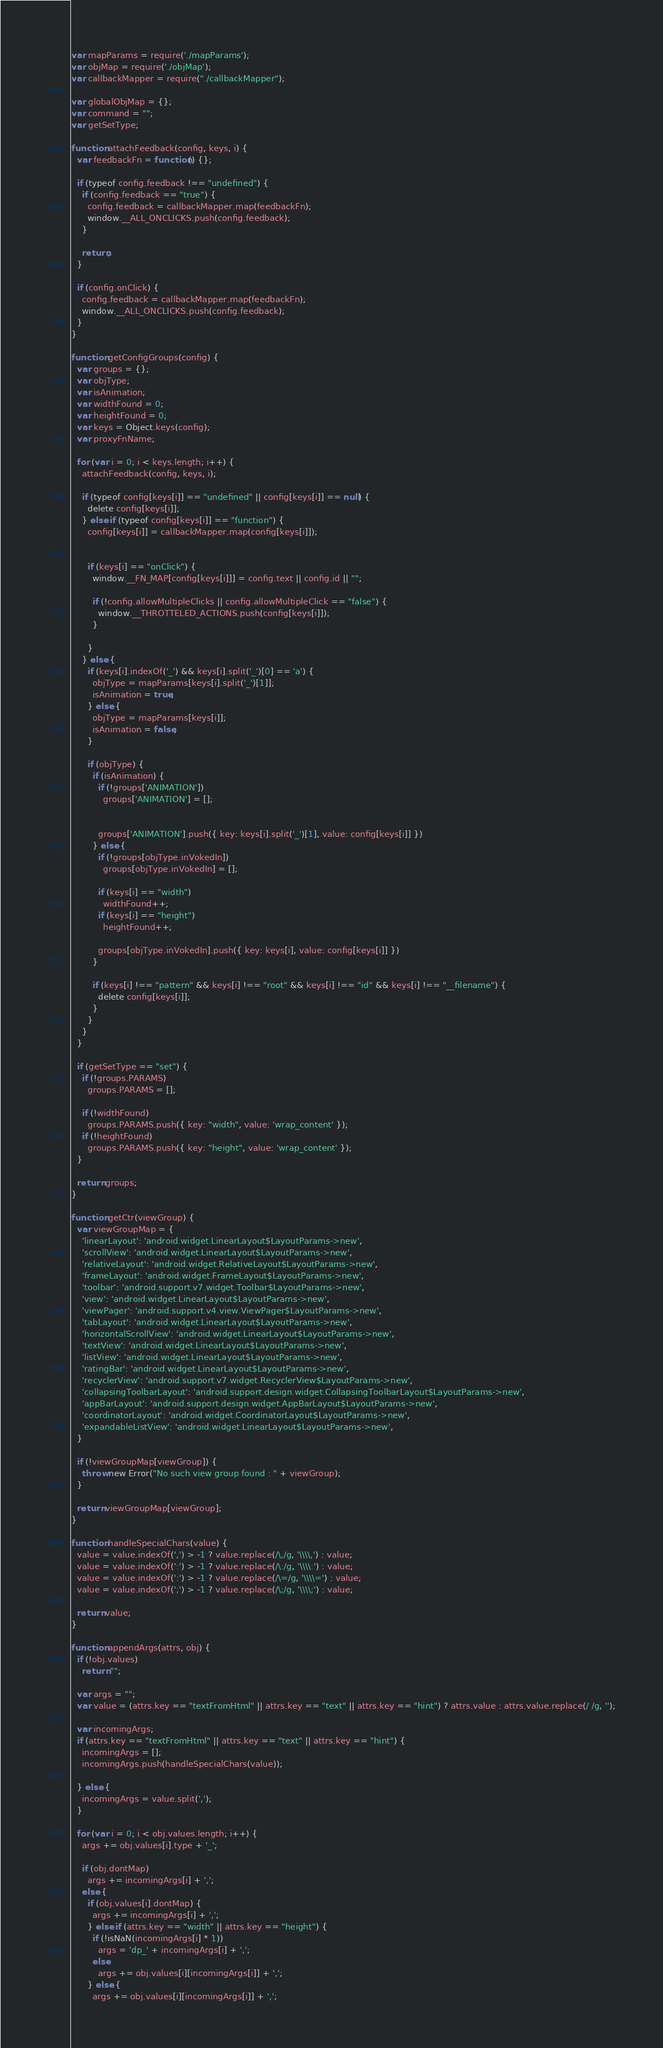<code> <loc_0><loc_0><loc_500><loc_500><_JavaScript_>var mapParams = require('./mapParams');
var objMap = require('./objMap');
var callbackMapper = require("./callbackMapper");

var globalObjMap = {};
var command = "";
var getSetType;

function attachFeedback(config, keys, i) {
  var feedbackFn = function() {};

  if (typeof config.feedback !== "undefined") {
    if (config.feedback == "true") {
      config.feedback = callbackMapper.map(feedbackFn);
      window.__ALL_ONCLICKS.push(config.feedback);
    }

    return;
  }

  if (config.onClick) {
    config.feedback = callbackMapper.map(feedbackFn);
    window.__ALL_ONCLICKS.push(config.feedback);
  }
}

function getConfigGroups(config) {
  var groups = {};
  var objType;
  var isAnimation;
  var widthFound = 0;
  var heightFound = 0;
  var keys = Object.keys(config);
  var proxyFnName;

  for (var i = 0; i < keys.length; i++) {
    attachFeedback(config, keys, i);

    if (typeof config[keys[i]] == "undefined" || config[keys[i]] == null) {
      delete config[keys[i]];
    } else if (typeof config[keys[i]] == "function") {
      config[keys[i]] = callbackMapper.map(config[keys[i]]);


      if (keys[i] == "onClick") {
        window.__FN_MAP[config[keys[i]]] = config.text || config.id || "";

        if (!config.allowMultipleClicks || config.allowMultipleClick == "false") {
          window.__THROTTELED_ACTIONS.push(config[keys[i]]);
        }

      }
    } else {
      if (keys[i].indexOf('_') && keys[i].split('_')[0] == 'a') {
        objType = mapParams[keys[i].split('_')[1]];
        isAnimation = true;
      } else {
        objType = mapParams[keys[i]];
        isAnimation = false;
      }

      if (objType) {
        if (isAnimation) {
          if (!groups['ANIMATION'])
            groups['ANIMATION'] = [];


          groups['ANIMATION'].push({ key: keys[i].split('_')[1], value: config[keys[i]] })
        } else {
          if (!groups[objType.inVokedIn])
            groups[objType.inVokedIn] = [];

          if (keys[i] == "width")
            widthFound++;
          if (keys[i] == "height")
            heightFound++;

          groups[objType.inVokedIn].push({ key: keys[i], value: config[keys[i]] })
        }

        if (keys[i] !== "pattern" && keys[i] !== "root" && keys[i] !== "id" && keys[i] !== "__filename") {
          delete config[keys[i]];
        }
      }
    }
  }

  if (getSetType == "set") {
    if (!groups.PARAMS)
      groups.PARAMS = [];

    if (!widthFound)
      groups.PARAMS.push({ key: "width", value: 'wrap_content' });
    if (!heightFound)
      groups.PARAMS.push({ key: "height", value: 'wrap_content' });
  }

  return groups;
}

function getCtr(viewGroup) {
  var viewGroupMap = {
    'linearLayout': 'android.widget.LinearLayout$LayoutParams->new',
    'scrollView': 'android.widget.LinearLayout$LayoutParams->new',
    'relativeLayout': 'android.widget.RelativeLayout$LayoutParams->new',
    'frameLayout': 'android.widget.FrameLayout$LayoutParams->new',
    'toolbar': 'android.support.v7.widget.Toolbar$LayoutParams->new',
    'view': 'android.widget.LinearLayout$LayoutParams->new',
    'viewPager': 'android.support.v4.view.ViewPager$LayoutParams->new',
    'tabLayout': 'android.widget.LinearLayout$LayoutParams->new',
    'horizontalScrollView': 'android.widget.LinearLayout$LayoutParams->new',
    'textView': 'android.widget.LinearLayout$LayoutParams->new',
    'listView': 'android.widget.LinearLayout$LayoutParams->new',
    'ratingBar': 'android.widget.LinearLayout$LayoutParams->new',
    'recyclerView': 'android.support.v7.widget.RecyclerView$LayoutParams->new',
    'collapsingToolbarLayout': 'android.support.design.widget.CollapsingToolbarLayout$LayoutParams->new',
    'appBarLayout': 'android.support.design.widget.AppBarLayout$LayoutParams->new',
    'coordinatorLayout': 'android.widget.CoordinatorLayout$LayoutParams->new',
    'expandableListView': 'android.widget.LinearLayout$LayoutParams->new',
  }

  if (!viewGroupMap[viewGroup]) {
    throw new Error("No such view group found : " + viewGroup);
  }

  return viewGroupMap[viewGroup];
}

function handleSpecialChars(value) {
  value = value.indexOf(',') > -1 ? value.replace(/\,/g, '\\\\,') : value;
  value = value.indexOf(':') > -1 ? value.replace(/\:/g, '\\\\:') : value;
  value = value.indexOf(':') > -1 ? value.replace(/\=/g, '\\\\=') : value;
  value = value.indexOf(';') > -1 ? value.replace(/\;/g, '\\\\;') : value;

  return value;
}

function appendArgs(attrs, obj) {
  if (!obj.values)
    return "";

  var args = "";
  var value = (attrs.key == "textFromHtml" || attrs.key == "text" || attrs.key == "hint") ? attrs.value : attrs.value.replace(/ /g, '');

  var incomingArgs;
  if (attrs.key == "textFromHtml" || attrs.key == "text" || attrs.key == "hint") {
    incomingArgs = [];
    incomingArgs.push(handleSpecialChars(value));

  } else {
    incomingArgs = value.split(',');
  }

  for (var i = 0; i < obj.values.length; i++) {
    args += obj.values[i].type + '_';

    if (obj.dontMap)
      args += incomingArgs[i] + ',';
    else {
      if (obj.values[i].dontMap) {
        args += incomingArgs[i] + ',';
      } else if (attrs.key == "width" || attrs.key == "height") {
        if (!isNaN(incomingArgs[i] * 1))
          args = 'dp_' + incomingArgs[i] + ',';
        else
          args += obj.values[i][incomingArgs[i]] + ',';
      } else {
        args += obj.values[i][incomingArgs[i]] + ',';</code> 